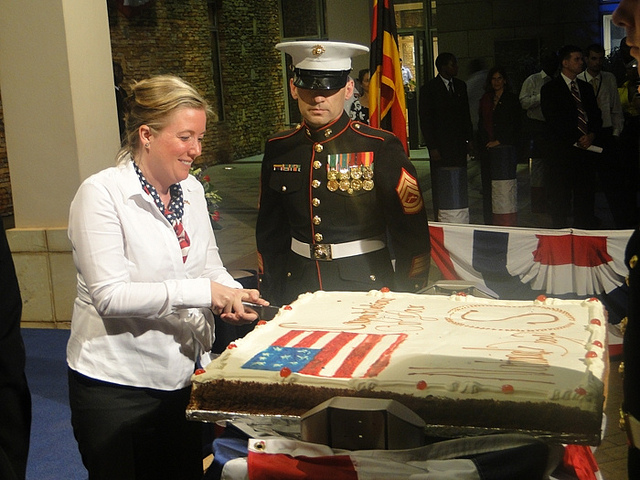Identify the text displayed in this image. S 